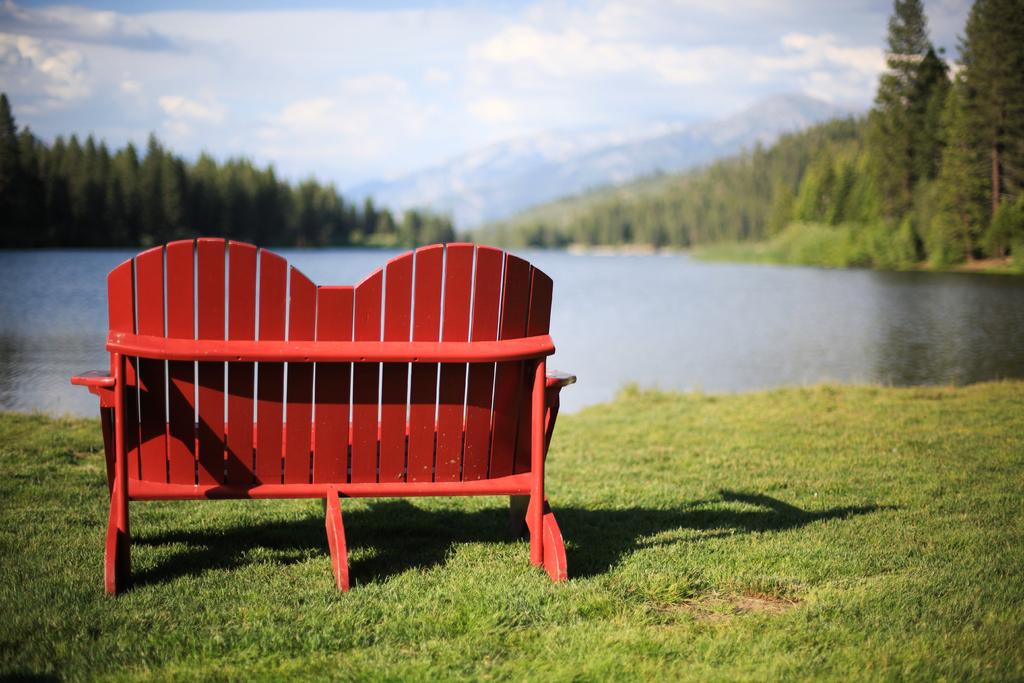What type of seating is located on the left side of the image? There is a bench chair on the left side of the image. What is the main feature in the middle of the image? There is water in the middle of the image. What type of vegetation is present on either side of the image? There are trees on either side of the image. What is visible at the top of the image? The sky is visible at the top of the image. What type of insurance is being discussed in the image? There is no discussion of insurance in the image; it features a bench chair, water, trees, and the sky. How many apples are visible in the image? There are no apples present in the image. 